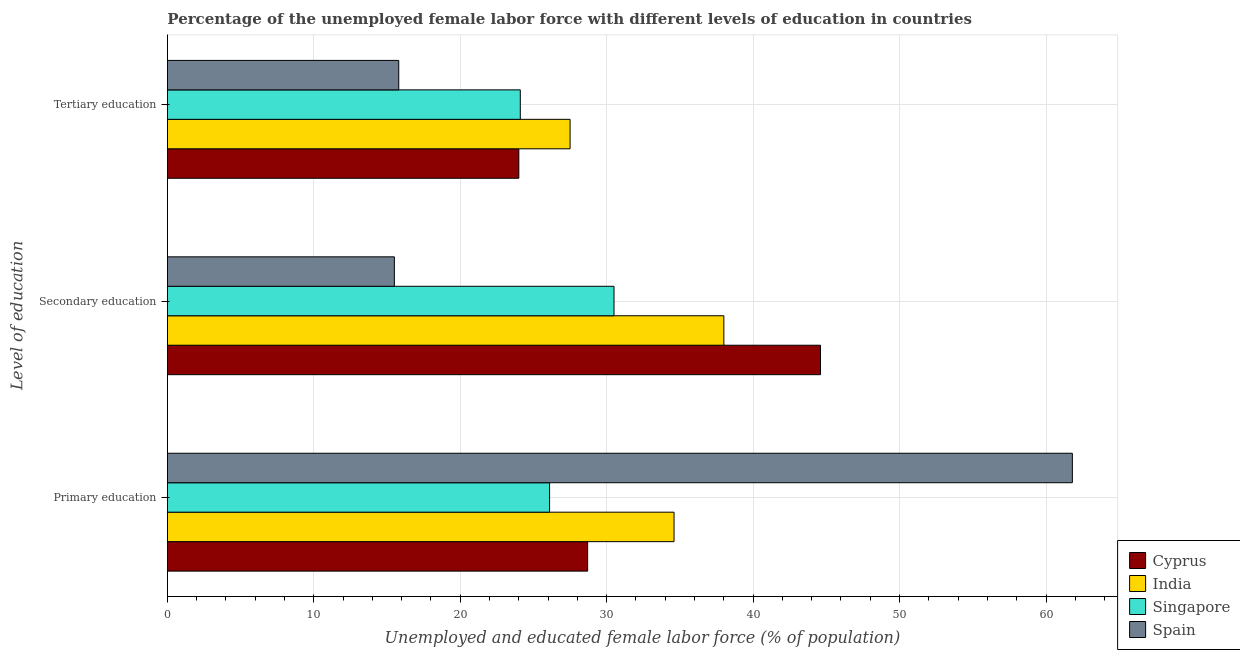How many different coloured bars are there?
Offer a very short reply. 4. Are the number of bars per tick equal to the number of legend labels?
Provide a short and direct response. Yes. Are the number of bars on each tick of the Y-axis equal?
Provide a short and direct response. Yes. What is the label of the 1st group of bars from the top?
Offer a very short reply. Tertiary education. What is the percentage of female labor force who received primary education in Spain?
Keep it short and to the point. 61.8. Across all countries, what is the maximum percentage of female labor force who received primary education?
Provide a short and direct response. 61.8. Across all countries, what is the minimum percentage of female labor force who received primary education?
Provide a short and direct response. 26.1. In which country was the percentage of female labor force who received secondary education maximum?
Offer a terse response. Cyprus. What is the total percentage of female labor force who received secondary education in the graph?
Provide a succinct answer. 128.6. What is the difference between the percentage of female labor force who received primary education in Singapore and the percentage of female labor force who received secondary education in Spain?
Give a very brief answer. 10.6. What is the average percentage of female labor force who received primary education per country?
Offer a very short reply. 37.8. What is the difference between the percentage of female labor force who received tertiary education and percentage of female labor force who received secondary education in Cyprus?
Your response must be concise. -20.6. In how many countries, is the percentage of female labor force who received primary education greater than 14 %?
Your response must be concise. 4. What is the ratio of the percentage of female labor force who received tertiary education in Singapore to that in Cyprus?
Provide a short and direct response. 1. Is the percentage of female labor force who received primary education in Spain less than that in Cyprus?
Make the answer very short. No. Is the difference between the percentage of female labor force who received secondary education in Singapore and Cyprus greater than the difference between the percentage of female labor force who received tertiary education in Singapore and Cyprus?
Offer a terse response. No. What is the difference between the highest and the second highest percentage of female labor force who received primary education?
Provide a short and direct response. 27.2. What is the difference between the highest and the lowest percentage of female labor force who received tertiary education?
Give a very brief answer. 11.7. What does the 1st bar from the bottom in Tertiary education represents?
Your answer should be compact. Cyprus. Is it the case that in every country, the sum of the percentage of female labor force who received primary education and percentage of female labor force who received secondary education is greater than the percentage of female labor force who received tertiary education?
Ensure brevity in your answer.  Yes. How many bars are there?
Make the answer very short. 12. What is the difference between two consecutive major ticks on the X-axis?
Your answer should be very brief. 10. Does the graph contain any zero values?
Provide a succinct answer. No. Does the graph contain grids?
Your answer should be very brief. Yes. Where does the legend appear in the graph?
Your response must be concise. Bottom right. How are the legend labels stacked?
Provide a succinct answer. Vertical. What is the title of the graph?
Keep it short and to the point. Percentage of the unemployed female labor force with different levels of education in countries. Does "Small states" appear as one of the legend labels in the graph?
Offer a terse response. No. What is the label or title of the X-axis?
Offer a very short reply. Unemployed and educated female labor force (% of population). What is the label or title of the Y-axis?
Offer a very short reply. Level of education. What is the Unemployed and educated female labor force (% of population) in Cyprus in Primary education?
Provide a succinct answer. 28.7. What is the Unemployed and educated female labor force (% of population) in India in Primary education?
Provide a short and direct response. 34.6. What is the Unemployed and educated female labor force (% of population) in Singapore in Primary education?
Ensure brevity in your answer.  26.1. What is the Unemployed and educated female labor force (% of population) in Spain in Primary education?
Provide a succinct answer. 61.8. What is the Unemployed and educated female labor force (% of population) of Cyprus in Secondary education?
Offer a terse response. 44.6. What is the Unemployed and educated female labor force (% of population) in Singapore in Secondary education?
Provide a short and direct response. 30.5. What is the Unemployed and educated female labor force (% of population) in Spain in Secondary education?
Provide a short and direct response. 15.5. What is the Unemployed and educated female labor force (% of population) in India in Tertiary education?
Offer a terse response. 27.5. What is the Unemployed and educated female labor force (% of population) of Singapore in Tertiary education?
Give a very brief answer. 24.1. What is the Unemployed and educated female labor force (% of population) in Spain in Tertiary education?
Offer a very short reply. 15.8. Across all Level of education, what is the maximum Unemployed and educated female labor force (% of population) in Cyprus?
Offer a very short reply. 44.6. Across all Level of education, what is the maximum Unemployed and educated female labor force (% of population) in Singapore?
Offer a very short reply. 30.5. Across all Level of education, what is the maximum Unemployed and educated female labor force (% of population) in Spain?
Give a very brief answer. 61.8. Across all Level of education, what is the minimum Unemployed and educated female labor force (% of population) of Singapore?
Offer a terse response. 24.1. What is the total Unemployed and educated female labor force (% of population) in Cyprus in the graph?
Ensure brevity in your answer.  97.3. What is the total Unemployed and educated female labor force (% of population) of India in the graph?
Make the answer very short. 100.1. What is the total Unemployed and educated female labor force (% of population) of Singapore in the graph?
Provide a short and direct response. 80.7. What is the total Unemployed and educated female labor force (% of population) in Spain in the graph?
Provide a short and direct response. 93.1. What is the difference between the Unemployed and educated female labor force (% of population) of Cyprus in Primary education and that in Secondary education?
Make the answer very short. -15.9. What is the difference between the Unemployed and educated female labor force (% of population) in Singapore in Primary education and that in Secondary education?
Give a very brief answer. -4.4. What is the difference between the Unemployed and educated female labor force (% of population) in Spain in Primary education and that in Secondary education?
Provide a short and direct response. 46.3. What is the difference between the Unemployed and educated female labor force (% of population) of Cyprus in Primary education and that in Tertiary education?
Your answer should be very brief. 4.7. What is the difference between the Unemployed and educated female labor force (% of population) of India in Primary education and that in Tertiary education?
Offer a terse response. 7.1. What is the difference between the Unemployed and educated female labor force (% of population) of Spain in Primary education and that in Tertiary education?
Keep it short and to the point. 46. What is the difference between the Unemployed and educated female labor force (% of population) of Cyprus in Secondary education and that in Tertiary education?
Make the answer very short. 20.6. What is the difference between the Unemployed and educated female labor force (% of population) in Singapore in Secondary education and that in Tertiary education?
Your answer should be compact. 6.4. What is the difference between the Unemployed and educated female labor force (% of population) of Spain in Secondary education and that in Tertiary education?
Your answer should be very brief. -0.3. What is the difference between the Unemployed and educated female labor force (% of population) of Cyprus in Primary education and the Unemployed and educated female labor force (% of population) of Singapore in Secondary education?
Give a very brief answer. -1.8. What is the difference between the Unemployed and educated female labor force (% of population) of Cyprus in Primary education and the Unemployed and educated female labor force (% of population) of Spain in Secondary education?
Ensure brevity in your answer.  13.2. What is the difference between the Unemployed and educated female labor force (% of population) of India in Primary education and the Unemployed and educated female labor force (% of population) of Spain in Secondary education?
Your answer should be compact. 19.1. What is the difference between the Unemployed and educated female labor force (% of population) of Cyprus in Primary education and the Unemployed and educated female labor force (% of population) of India in Tertiary education?
Offer a terse response. 1.2. What is the difference between the Unemployed and educated female labor force (% of population) in Cyprus in Primary education and the Unemployed and educated female labor force (% of population) in Singapore in Tertiary education?
Your answer should be very brief. 4.6. What is the difference between the Unemployed and educated female labor force (% of population) in Singapore in Primary education and the Unemployed and educated female labor force (% of population) in Spain in Tertiary education?
Your response must be concise. 10.3. What is the difference between the Unemployed and educated female labor force (% of population) of Cyprus in Secondary education and the Unemployed and educated female labor force (% of population) of India in Tertiary education?
Your answer should be very brief. 17.1. What is the difference between the Unemployed and educated female labor force (% of population) of Cyprus in Secondary education and the Unemployed and educated female labor force (% of population) of Spain in Tertiary education?
Your answer should be very brief. 28.8. What is the difference between the Unemployed and educated female labor force (% of population) in India in Secondary education and the Unemployed and educated female labor force (% of population) in Spain in Tertiary education?
Provide a short and direct response. 22.2. What is the average Unemployed and educated female labor force (% of population) of Cyprus per Level of education?
Make the answer very short. 32.43. What is the average Unemployed and educated female labor force (% of population) of India per Level of education?
Offer a terse response. 33.37. What is the average Unemployed and educated female labor force (% of population) of Singapore per Level of education?
Offer a terse response. 26.9. What is the average Unemployed and educated female labor force (% of population) in Spain per Level of education?
Provide a short and direct response. 31.03. What is the difference between the Unemployed and educated female labor force (% of population) in Cyprus and Unemployed and educated female labor force (% of population) in India in Primary education?
Offer a very short reply. -5.9. What is the difference between the Unemployed and educated female labor force (% of population) in Cyprus and Unemployed and educated female labor force (% of population) in Spain in Primary education?
Give a very brief answer. -33.1. What is the difference between the Unemployed and educated female labor force (% of population) in India and Unemployed and educated female labor force (% of population) in Singapore in Primary education?
Ensure brevity in your answer.  8.5. What is the difference between the Unemployed and educated female labor force (% of population) in India and Unemployed and educated female labor force (% of population) in Spain in Primary education?
Offer a terse response. -27.2. What is the difference between the Unemployed and educated female labor force (% of population) of Singapore and Unemployed and educated female labor force (% of population) of Spain in Primary education?
Your answer should be very brief. -35.7. What is the difference between the Unemployed and educated female labor force (% of population) in Cyprus and Unemployed and educated female labor force (% of population) in Singapore in Secondary education?
Ensure brevity in your answer.  14.1. What is the difference between the Unemployed and educated female labor force (% of population) in Cyprus and Unemployed and educated female labor force (% of population) in Spain in Secondary education?
Ensure brevity in your answer.  29.1. What is the difference between the Unemployed and educated female labor force (% of population) in India and Unemployed and educated female labor force (% of population) in Singapore in Secondary education?
Keep it short and to the point. 7.5. What is the difference between the Unemployed and educated female labor force (% of population) in India and Unemployed and educated female labor force (% of population) in Spain in Secondary education?
Your answer should be compact. 22.5. What is the difference between the Unemployed and educated female labor force (% of population) in Singapore and Unemployed and educated female labor force (% of population) in Spain in Secondary education?
Your answer should be very brief. 15. What is the difference between the Unemployed and educated female labor force (% of population) in Cyprus and Unemployed and educated female labor force (% of population) in India in Tertiary education?
Provide a short and direct response. -3.5. What is the difference between the Unemployed and educated female labor force (% of population) in India and Unemployed and educated female labor force (% of population) in Singapore in Tertiary education?
Offer a very short reply. 3.4. What is the difference between the Unemployed and educated female labor force (% of population) in India and Unemployed and educated female labor force (% of population) in Spain in Tertiary education?
Keep it short and to the point. 11.7. What is the ratio of the Unemployed and educated female labor force (% of population) in Cyprus in Primary education to that in Secondary education?
Ensure brevity in your answer.  0.64. What is the ratio of the Unemployed and educated female labor force (% of population) in India in Primary education to that in Secondary education?
Your response must be concise. 0.91. What is the ratio of the Unemployed and educated female labor force (% of population) in Singapore in Primary education to that in Secondary education?
Give a very brief answer. 0.86. What is the ratio of the Unemployed and educated female labor force (% of population) of Spain in Primary education to that in Secondary education?
Provide a succinct answer. 3.99. What is the ratio of the Unemployed and educated female labor force (% of population) in Cyprus in Primary education to that in Tertiary education?
Offer a very short reply. 1.2. What is the ratio of the Unemployed and educated female labor force (% of population) of India in Primary education to that in Tertiary education?
Provide a succinct answer. 1.26. What is the ratio of the Unemployed and educated female labor force (% of population) of Singapore in Primary education to that in Tertiary education?
Offer a very short reply. 1.08. What is the ratio of the Unemployed and educated female labor force (% of population) in Spain in Primary education to that in Tertiary education?
Your response must be concise. 3.91. What is the ratio of the Unemployed and educated female labor force (% of population) in Cyprus in Secondary education to that in Tertiary education?
Your response must be concise. 1.86. What is the ratio of the Unemployed and educated female labor force (% of population) in India in Secondary education to that in Tertiary education?
Keep it short and to the point. 1.38. What is the ratio of the Unemployed and educated female labor force (% of population) of Singapore in Secondary education to that in Tertiary education?
Your response must be concise. 1.27. What is the difference between the highest and the second highest Unemployed and educated female labor force (% of population) in Cyprus?
Your answer should be compact. 15.9. What is the difference between the highest and the second highest Unemployed and educated female labor force (% of population) in Singapore?
Your answer should be very brief. 4.4. What is the difference between the highest and the second highest Unemployed and educated female labor force (% of population) of Spain?
Provide a short and direct response. 46. What is the difference between the highest and the lowest Unemployed and educated female labor force (% of population) in Cyprus?
Provide a short and direct response. 20.6. What is the difference between the highest and the lowest Unemployed and educated female labor force (% of population) in India?
Provide a short and direct response. 10.5. What is the difference between the highest and the lowest Unemployed and educated female labor force (% of population) of Spain?
Your response must be concise. 46.3. 